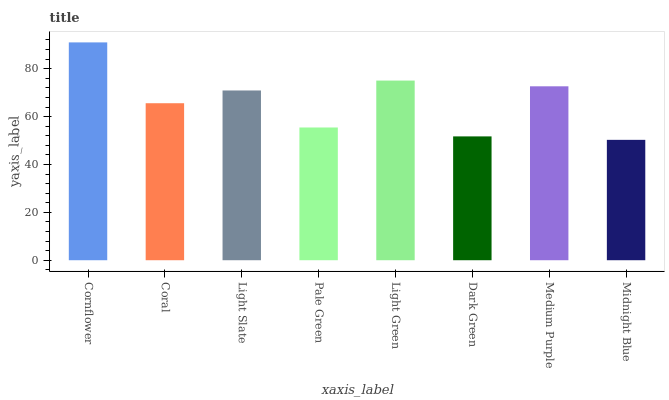Is Coral the minimum?
Answer yes or no. No. Is Coral the maximum?
Answer yes or no. No. Is Cornflower greater than Coral?
Answer yes or no. Yes. Is Coral less than Cornflower?
Answer yes or no. Yes. Is Coral greater than Cornflower?
Answer yes or no. No. Is Cornflower less than Coral?
Answer yes or no. No. Is Light Slate the high median?
Answer yes or no. Yes. Is Coral the low median?
Answer yes or no. Yes. Is Medium Purple the high median?
Answer yes or no. No. Is Medium Purple the low median?
Answer yes or no. No. 